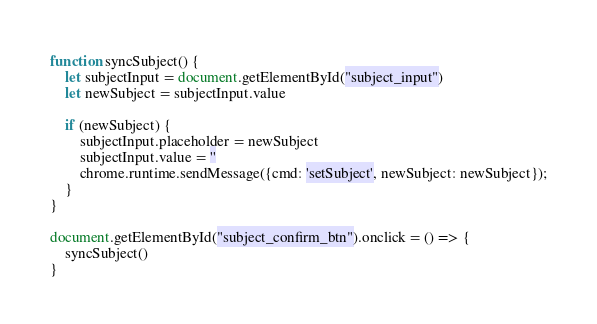Convert code to text. <code><loc_0><loc_0><loc_500><loc_500><_JavaScript_>
function syncSubject() {
    let subjectInput = document.getElementById("subject_input")
    let newSubject = subjectInput.value

    if (newSubject) {
        subjectInput.placeholder = newSubject
        subjectInput.value = ''
        chrome.runtime.sendMessage({cmd: 'setSubject', newSubject: newSubject});
    }
}

document.getElementById("subject_confirm_btn").onclick = () => {
    syncSubject()
}
</code> 